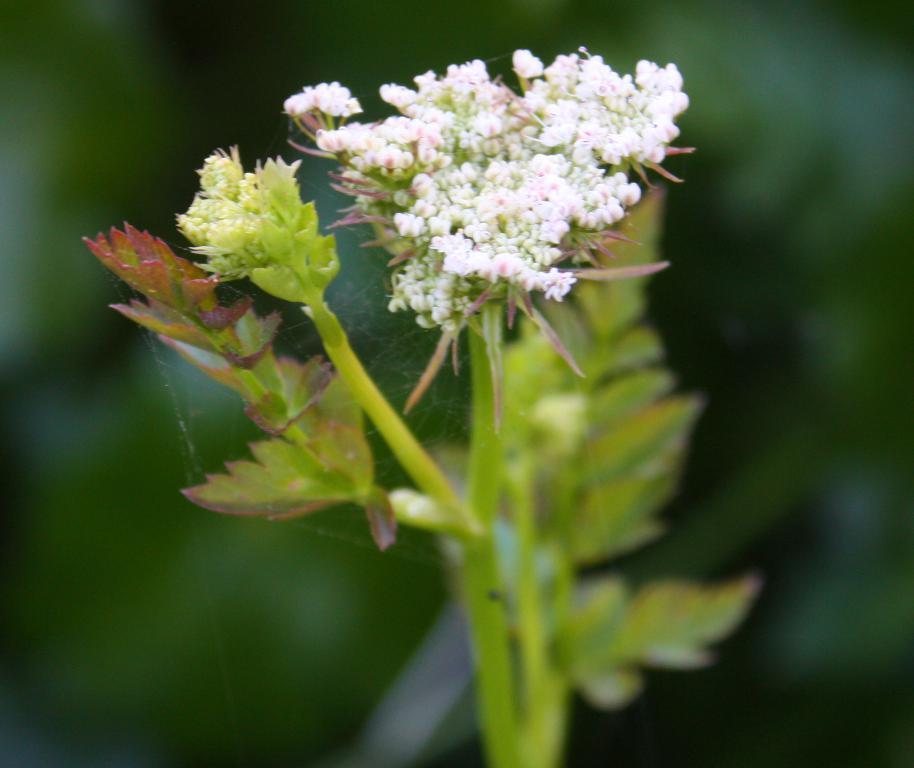Please provide a concise description of this image. In this image we can see plants with flowers. In the background the image is blur but we can see objects. 